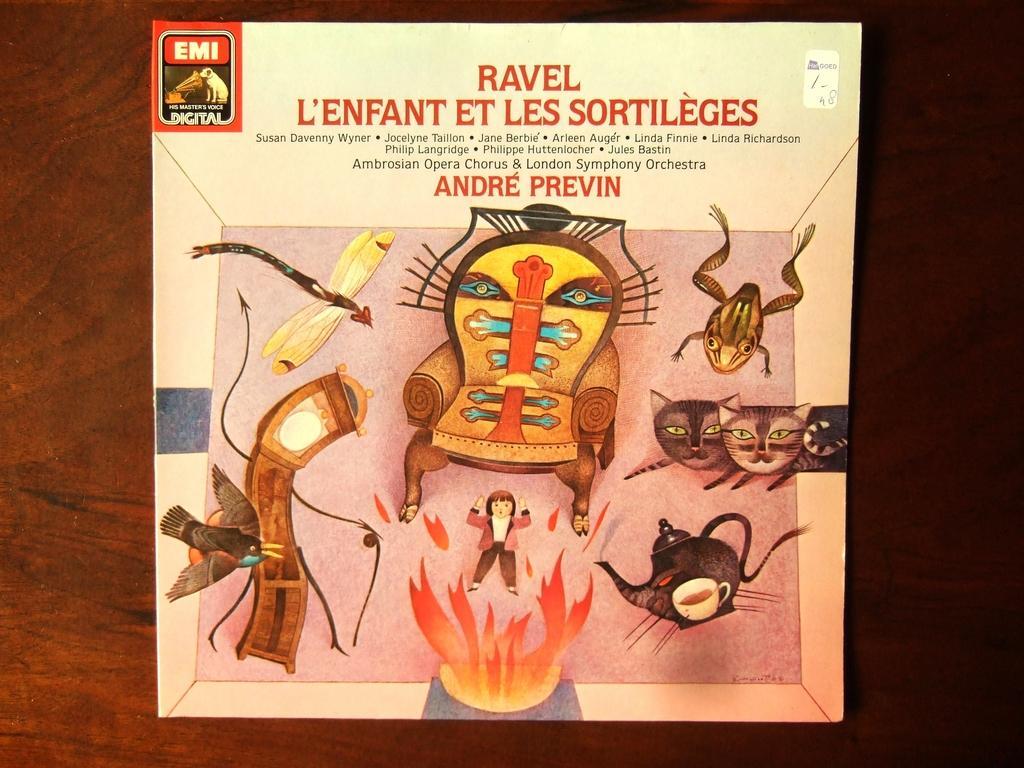Can you describe this image briefly? In this picture there is a poster which is placed on the table. In that poster I can see some animals like a bird, fly, frog and cats. In the center of the poster there is a chair. At the bottom of the poster I can see the person who is a standing about the fire. In the bottom right corner of the poster I can see the tea cup and jar. 